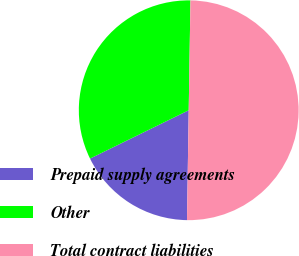Convert chart. <chart><loc_0><loc_0><loc_500><loc_500><pie_chart><fcel>Prepaid supply agreements<fcel>Other<fcel>Total contract liabilities<nl><fcel>17.5%<fcel>32.5%<fcel>50.0%<nl></chart> 